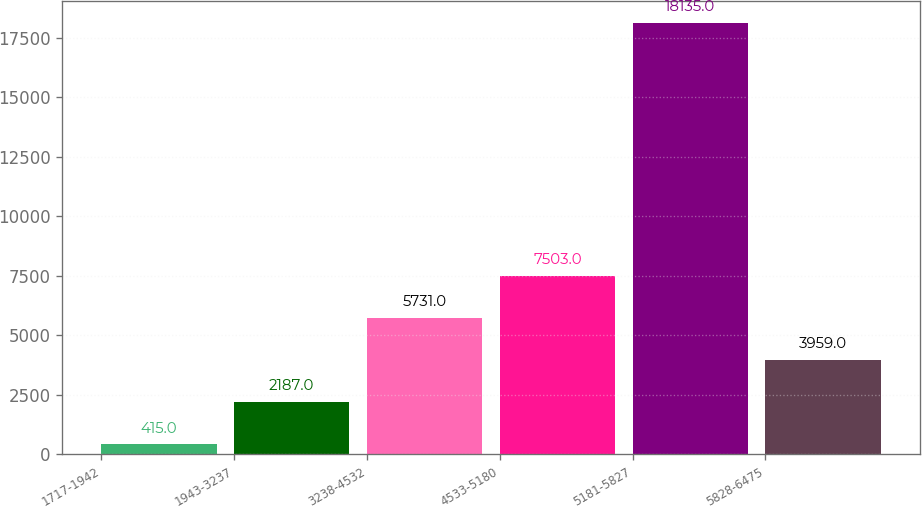Convert chart to OTSL. <chart><loc_0><loc_0><loc_500><loc_500><bar_chart><fcel>1717-1942<fcel>1943-3237<fcel>3238-4532<fcel>4533-5180<fcel>5181-5827<fcel>5828-6475<nl><fcel>415<fcel>2187<fcel>5731<fcel>7503<fcel>18135<fcel>3959<nl></chart> 